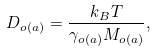Convert formula to latex. <formula><loc_0><loc_0><loc_500><loc_500>D _ { o \left ( a \right ) } = \frac { k _ { B } T } { \gamma _ { o \left ( a \right ) } M _ { o \left ( a \right ) } } ,</formula> 